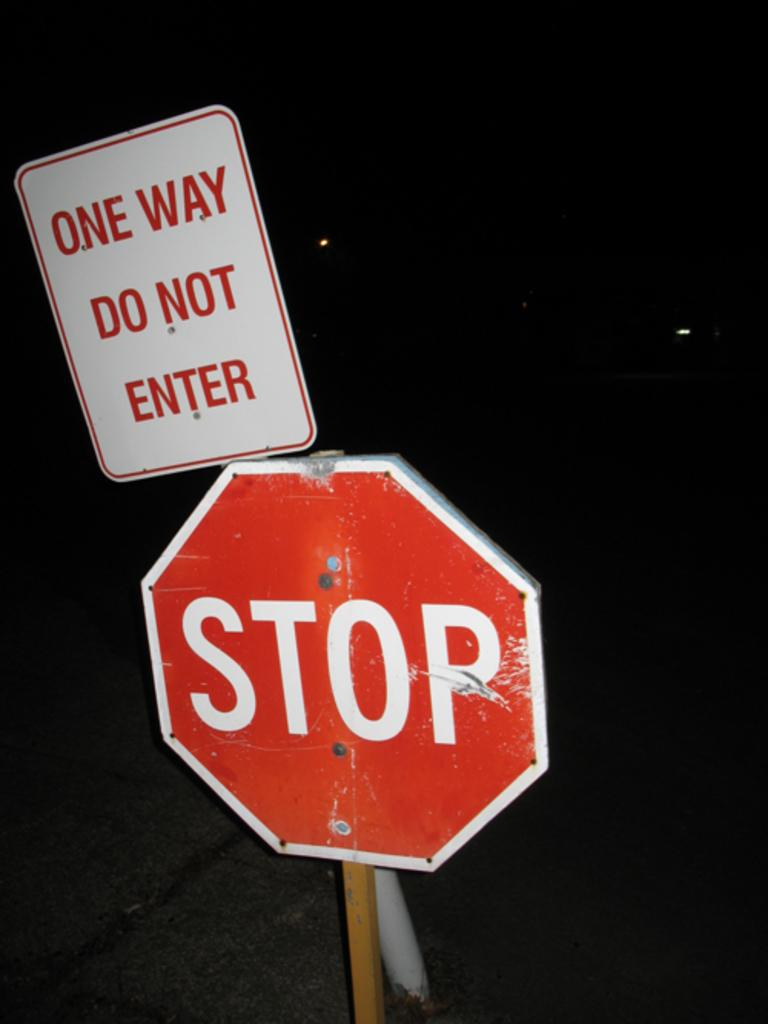<image>
Give a short and clear explanation of the subsequent image. A one way do not enter sign leaning on a stop sign. 